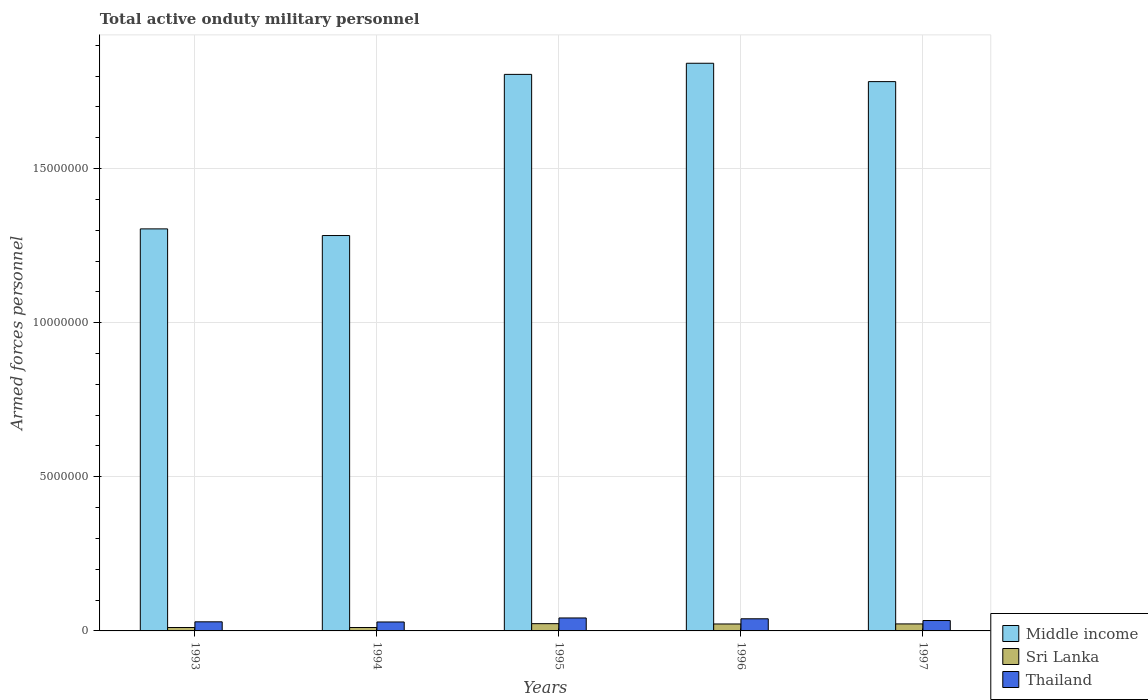How many different coloured bars are there?
Offer a very short reply. 3. How many bars are there on the 4th tick from the right?
Ensure brevity in your answer.  3. In how many cases, is the number of bars for a given year not equal to the number of legend labels?
Ensure brevity in your answer.  0. What is the number of armed forces personnel in Middle income in 1993?
Provide a succinct answer. 1.30e+07. Across all years, what is the maximum number of armed forces personnel in Thailand?
Ensure brevity in your answer.  4.20e+05. Across all years, what is the minimum number of armed forces personnel in Middle income?
Provide a short and direct response. 1.28e+07. What is the total number of armed forces personnel in Sri Lanka in the graph?
Make the answer very short. 9.08e+05. What is the difference between the number of armed forces personnel in Sri Lanka in 1993 and that in 1995?
Provide a succinct answer. -1.26e+05. What is the difference between the number of armed forces personnel in Thailand in 1993 and the number of armed forces personnel in Middle income in 1996?
Offer a very short reply. -1.81e+07. What is the average number of armed forces personnel in Middle income per year?
Offer a terse response. 1.60e+07. In the year 1995, what is the difference between the number of armed forces personnel in Middle income and number of armed forces personnel in Sri Lanka?
Keep it short and to the point. 1.78e+07. What is the ratio of the number of armed forces personnel in Thailand in 1993 to that in 1997?
Offer a terse response. 0.88. Is the difference between the number of armed forces personnel in Middle income in 1993 and 1996 greater than the difference between the number of armed forces personnel in Sri Lanka in 1993 and 1996?
Provide a succinct answer. No. What is the difference between the highest and the second highest number of armed forces personnel in Middle income?
Your response must be concise. 3.61e+05. What is the difference between the highest and the lowest number of armed forces personnel in Sri Lanka?
Provide a short and direct response. 1.26e+05. In how many years, is the number of armed forces personnel in Middle income greater than the average number of armed forces personnel in Middle income taken over all years?
Your response must be concise. 3. Is the sum of the number of armed forces personnel in Middle income in 1993 and 1994 greater than the maximum number of armed forces personnel in Sri Lanka across all years?
Ensure brevity in your answer.  Yes. What does the 2nd bar from the left in 1995 represents?
Keep it short and to the point. Sri Lanka. What does the 3rd bar from the right in 1993 represents?
Your answer should be compact. Middle income. Are all the bars in the graph horizontal?
Provide a succinct answer. No. How many years are there in the graph?
Your answer should be compact. 5. What is the difference between two consecutive major ticks on the Y-axis?
Your answer should be very brief. 5.00e+06. Are the values on the major ticks of Y-axis written in scientific E-notation?
Keep it short and to the point. No. Where does the legend appear in the graph?
Ensure brevity in your answer.  Bottom right. How many legend labels are there?
Your response must be concise. 3. What is the title of the graph?
Your answer should be compact. Total active onduty military personnel. What is the label or title of the X-axis?
Offer a very short reply. Years. What is the label or title of the Y-axis?
Give a very brief answer. Armed forces personnel. What is the Armed forces personnel of Middle income in 1993?
Your answer should be very brief. 1.30e+07. What is the Armed forces personnel of Sri Lanka in 1993?
Provide a short and direct response. 1.10e+05. What is the Armed forces personnel in Thailand in 1993?
Offer a terse response. 2.95e+05. What is the Armed forces personnel of Middle income in 1994?
Provide a succinct answer. 1.28e+07. What is the Armed forces personnel of Sri Lanka in 1994?
Give a very brief answer. 1.10e+05. What is the Armed forces personnel of Thailand in 1994?
Your response must be concise. 2.90e+05. What is the Armed forces personnel in Middle income in 1995?
Your answer should be compact. 1.81e+07. What is the Armed forces personnel in Sri Lanka in 1995?
Offer a very short reply. 2.36e+05. What is the Armed forces personnel of Thailand in 1995?
Your response must be concise. 4.20e+05. What is the Armed forces personnel of Middle income in 1996?
Offer a terse response. 1.84e+07. What is the Armed forces personnel in Sri Lanka in 1996?
Give a very brief answer. 2.25e+05. What is the Armed forces personnel of Thailand in 1996?
Make the answer very short. 3.94e+05. What is the Armed forces personnel in Middle income in 1997?
Provide a succinct answer. 1.78e+07. What is the Armed forces personnel in Sri Lanka in 1997?
Offer a very short reply. 2.27e+05. What is the Armed forces personnel of Thailand in 1997?
Offer a terse response. 3.37e+05. Across all years, what is the maximum Armed forces personnel of Middle income?
Offer a terse response. 1.84e+07. Across all years, what is the maximum Armed forces personnel of Sri Lanka?
Give a very brief answer. 2.36e+05. Across all years, what is the maximum Armed forces personnel in Thailand?
Keep it short and to the point. 4.20e+05. Across all years, what is the minimum Armed forces personnel in Middle income?
Your answer should be compact. 1.28e+07. What is the total Armed forces personnel of Middle income in the graph?
Your response must be concise. 8.02e+07. What is the total Armed forces personnel of Sri Lanka in the graph?
Provide a short and direct response. 9.08e+05. What is the total Armed forces personnel of Thailand in the graph?
Give a very brief answer. 1.74e+06. What is the difference between the Armed forces personnel of Middle income in 1993 and that in 1994?
Make the answer very short. 2.16e+05. What is the difference between the Armed forces personnel of Sri Lanka in 1993 and that in 1994?
Your answer should be very brief. 0. What is the difference between the Armed forces personnel in Thailand in 1993 and that in 1994?
Your response must be concise. 5000. What is the difference between the Armed forces personnel in Middle income in 1993 and that in 1995?
Offer a very short reply. -5.01e+06. What is the difference between the Armed forces personnel of Sri Lanka in 1993 and that in 1995?
Offer a terse response. -1.26e+05. What is the difference between the Armed forces personnel in Thailand in 1993 and that in 1995?
Make the answer very short. -1.26e+05. What is the difference between the Armed forces personnel of Middle income in 1993 and that in 1996?
Keep it short and to the point. -5.37e+06. What is the difference between the Armed forces personnel in Sri Lanka in 1993 and that in 1996?
Your answer should be compact. -1.15e+05. What is the difference between the Armed forces personnel in Thailand in 1993 and that in 1996?
Your answer should be compact. -9.85e+04. What is the difference between the Armed forces personnel in Middle income in 1993 and that in 1997?
Provide a short and direct response. -4.78e+06. What is the difference between the Armed forces personnel of Sri Lanka in 1993 and that in 1997?
Make the answer very short. -1.17e+05. What is the difference between the Armed forces personnel of Thailand in 1993 and that in 1997?
Provide a short and direct response. -4.20e+04. What is the difference between the Armed forces personnel in Middle income in 1994 and that in 1995?
Provide a short and direct response. -5.23e+06. What is the difference between the Armed forces personnel of Sri Lanka in 1994 and that in 1995?
Your answer should be very brief. -1.26e+05. What is the difference between the Armed forces personnel in Thailand in 1994 and that in 1995?
Your response must be concise. -1.30e+05. What is the difference between the Armed forces personnel in Middle income in 1994 and that in 1996?
Provide a short and direct response. -5.59e+06. What is the difference between the Armed forces personnel in Sri Lanka in 1994 and that in 1996?
Offer a terse response. -1.15e+05. What is the difference between the Armed forces personnel in Thailand in 1994 and that in 1996?
Ensure brevity in your answer.  -1.04e+05. What is the difference between the Armed forces personnel of Middle income in 1994 and that in 1997?
Keep it short and to the point. -4.99e+06. What is the difference between the Armed forces personnel of Sri Lanka in 1994 and that in 1997?
Give a very brief answer. -1.17e+05. What is the difference between the Armed forces personnel in Thailand in 1994 and that in 1997?
Your answer should be compact. -4.70e+04. What is the difference between the Armed forces personnel of Middle income in 1995 and that in 1996?
Keep it short and to the point. -3.61e+05. What is the difference between the Armed forces personnel in Sri Lanka in 1995 and that in 1996?
Keep it short and to the point. 1.03e+04. What is the difference between the Armed forces personnel in Thailand in 1995 and that in 1996?
Offer a very short reply. 2.70e+04. What is the difference between the Armed forces personnel in Middle income in 1995 and that in 1997?
Your response must be concise. 2.35e+05. What is the difference between the Armed forces personnel of Sri Lanka in 1995 and that in 1997?
Give a very brief answer. 8300. What is the difference between the Armed forces personnel in Thailand in 1995 and that in 1997?
Offer a very short reply. 8.35e+04. What is the difference between the Armed forces personnel in Middle income in 1996 and that in 1997?
Provide a short and direct response. 5.96e+05. What is the difference between the Armed forces personnel of Sri Lanka in 1996 and that in 1997?
Offer a very short reply. -2000. What is the difference between the Armed forces personnel in Thailand in 1996 and that in 1997?
Offer a very short reply. 5.65e+04. What is the difference between the Armed forces personnel of Middle income in 1993 and the Armed forces personnel of Sri Lanka in 1994?
Offer a terse response. 1.29e+07. What is the difference between the Armed forces personnel in Middle income in 1993 and the Armed forces personnel in Thailand in 1994?
Provide a short and direct response. 1.28e+07. What is the difference between the Armed forces personnel in Sri Lanka in 1993 and the Armed forces personnel in Thailand in 1994?
Your response must be concise. -1.80e+05. What is the difference between the Armed forces personnel of Middle income in 1993 and the Armed forces personnel of Sri Lanka in 1995?
Keep it short and to the point. 1.28e+07. What is the difference between the Armed forces personnel in Middle income in 1993 and the Armed forces personnel in Thailand in 1995?
Your response must be concise. 1.26e+07. What is the difference between the Armed forces personnel of Sri Lanka in 1993 and the Armed forces personnel of Thailand in 1995?
Make the answer very short. -3.10e+05. What is the difference between the Armed forces personnel in Middle income in 1993 and the Armed forces personnel in Sri Lanka in 1996?
Give a very brief answer. 1.28e+07. What is the difference between the Armed forces personnel of Middle income in 1993 and the Armed forces personnel of Thailand in 1996?
Your response must be concise. 1.26e+07. What is the difference between the Armed forces personnel of Sri Lanka in 1993 and the Armed forces personnel of Thailand in 1996?
Make the answer very short. -2.84e+05. What is the difference between the Armed forces personnel of Middle income in 1993 and the Armed forces personnel of Sri Lanka in 1997?
Offer a very short reply. 1.28e+07. What is the difference between the Armed forces personnel in Middle income in 1993 and the Armed forces personnel in Thailand in 1997?
Keep it short and to the point. 1.27e+07. What is the difference between the Armed forces personnel in Sri Lanka in 1993 and the Armed forces personnel in Thailand in 1997?
Offer a very short reply. -2.27e+05. What is the difference between the Armed forces personnel in Middle income in 1994 and the Armed forces personnel in Sri Lanka in 1995?
Provide a short and direct response. 1.26e+07. What is the difference between the Armed forces personnel of Middle income in 1994 and the Armed forces personnel of Thailand in 1995?
Provide a succinct answer. 1.24e+07. What is the difference between the Armed forces personnel in Sri Lanka in 1994 and the Armed forces personnel in Thailand in 1995?
Your answer should be compact. -3.10e+05. What is the difference between the Armed forces personnel of Middle income in 1994 and the Armed forces personnel of Sri Lanka in 1996?
Your response must be concise. 1.26e+07. What is the difference between the Armed forces personnel of Middle income in 1994 and the Armed forces personnel of Thailand in 1996?
Offer a terse response. 1.24e+07. What is the difference between the Armed forces personnel of Sri Lanka in 1994 and the Armed forces personnel of Thailand in 1996?
Your answer should be compact. -2.84e+05. What is the difference between the Armed forces personnel in Middle income in 1994 and the Armed forces personnel in Sri Lanka in 1997?
Give a very brief answer. 1.26e+07. What is the difference between the Armed forces personnel in Middle income in 1994 and the Armed forces personnel in Thailand in 1997?
Your response must be concise. 1.25e+07. What is the difference between the Armed forces personnel in Sri Lanka in 1994 and the Armed forces personnel in Thailand in 1997?
Your response must be concise. -2.27e+05. What is the difference between the Armed forces personnel in Middle income in 1995 and the Armed forces personnel in Sri Lanka in 1996?
Your answer should be very brief. 1.78e+07. What is the difference between the Armed forces personnel of Middle income in 1995 and the Armed forces personnel of Thailand in 1996?
Offer a terse response. 1.77e+07. What is the difference between the Armed forces personnel of Sri Lanka in 1995 and the Armed forces personnel of Thailand in 1996?
Give a very brief answer. -1.58e+05. What is the difference between the Armed forces personnel of Middle income in 1995 and the Armed forces personnel of Sri Lanka in 1997?
Ensure brevity in your answer.  1.78e+07. What is the difference between the Armed forces personnel of Middle income in 1995 and the Armed forces personnel of Thailand in 1997?
Offer a terse response. 1.77e+07. What is the difference between the Armed forces personnel of Sri Lanka in 1995 and the Armed forces personnel of Thailand in 1997?
Your answer should be very brief. -1.02e+05. What is the difference between the Armed forces personnel in Middle income in 1996 and the Armed forces personnel in Sri Lanka in 1997?
Make the answer very short. 1.82e+07. What is the difference between the Armed forces personnel of Middle income in 1996 and the Armed forces personnel of Thailand in 1997?
Your response must be concise. 1.81e+07. What is the difference between the Armed forces personnel of Sri Lanka in 1996 and the Armed forces personnel of Thailand in 1997?
Your answer should be compact. -1.12e+05. What is the average Armed forces personnel in Middle income per year?
Offer a very short reply. 1.60e+07. What is the average Armed forces personnel of Sri Lanka per year?
Offer a very short reply. 1.82e+05. What is the average Armed forces personnel of Thailand per year?
Ensure brevity in your answer.  3.47e+05. In the year 1993, what is the difference between the Armed forces personnel in Middle income and Armed forces personnel in Sri Lanka?
Make the answer very short. 1.29e+07. In the year 1993, what is the difference between the Armed forces personnel of Middle income and Armed forces personnel of Thailand?
Offer a very short reply. 1.27e+07. In the year 1993, what is the difference between the Armed forces personnel in Sri Lanka and Armed forces personnel in Thailand?
Offer a very short reply. -1.85e+05. In the year 1994, what is the difference between the Armed forces personnel of Middle income and Armed forces personnel of Sri Lanka?
Your response must be concise. 1.27e+07. In the year 1994, what is the difference between the Armed forces personnel in Middle income and Armed forces personnel in Thailand?
Provide a short and direct response. 1.25e+07. In the year 1995, what is the difference between the Armed forces personnel in Middle income and Armed forces personnel in Sri Lanka?
Your answer should be compact. 1.78e+07. In the year 1995, what is the difference between the Armed forces personnel of Middle income and Armed forces personnel of Thailand?
Your answer should be very brief. 1.76e+07. In the year 1995, what is the difference between the Armed forces personnel in Sri Lanka and Armed forces personnel in Thailand?
Give a very brief answer. -1.85e+05. In the year 1996, what is the difference between the Armed forces personnel of Middle income and Armed forces personnel of Sri Lanka?
Provide a succinct answer. 1.82e+07. In the year 1996, what is the difference between the Armed forces personnel in Middle income and Armed forces personnel in Thailand?
Ensure brevity in your answer.  1.80e+07. In the year 1996, what is the difference between the Armed forces personnel in Sri Lanka and Armed forces personnel in Thailand?
Make the answer very short. -1.68e+05. In the year 1997, what is the difference between the Armed forces personnel in Middle income and Armed forces personnel in Sri Lanka?
Make the answer very short. 1.76e+07. In the year 1997, what is the difference between the Armed forces personnel in Middle income and Armed forces personnel in Thailand?
Provide a short and direct response. 1.75e+07. In the year 1997, what is the difference between the Armed forces personnel of Sri Lanka and Armed forces personnel of Thailand?
Provide a short and direct response. -1.10e+05. What is the ratio of the Armed forces personnel of Middle income in 1993 to that in 1994?
Give a very brief answer. 1.02. What is the ratio of the Armed forces personnel in Sri Lanka in 1993 to that in 1994?
Offer a terse response. 1. What is the ratio of the Armed forces personnel of Thailand in 1993 to that in 1994?
Provide a short and direct response. 1.02. What is the ratio of the Armed forces personnel of Middle income in 1993 to that in 1995?
Ensure brevity in your answer.  0.72. What is the ratio of the Armed forces personnel of Sri Lanka in 1993 to that in 1995?
Make the answer very short. 0.47. What is the ratio of the Armed forces personnel in Thailand in 1993 to that in 1995?
Provide a succinct answer. 0.7. What is the ratio of the Armed forces personnel in Middle income in 1993 to that in 1996?
Make the answer very short. 0.71. What is the ratio of the Armed forces personnel in Sri Lanka in 1993 to that in 1996?
Provide a short and direct response. 0.49. What is the ratio of the Armed forces personnel of Thailand in 1993 to that in 1996?
Offer a terse response. 0.75. What is the ratio of the Armed forces personnel in Middle income in 1993 to that in 1997?
Your response must be concise. 0.73. What is the ratio of the Armed forces personnel of Sri Lanka in 1993 to that in 1997?
Your answer should be very brief. 0.48. What is the ratio of the Armed forces personnel in Thailand in 1993 to that in 1997?
Offer a terse response. 0.88. What is the ratio of the Armed forces personnel in Middle income in 1994 to that in 1995?
Offer a very short reply. 0.71. What is the ratio of the Armed forces personnel of Sri Lanka in 1994 to that in 1995?
Provide a short and direct response. 0.47. What is the ratio of the Armed forces personnel of Thailand in 1994 to that in 1995?
Your answer should be very brief. 0.69. What is the ratio of the Armed forces personnel of Middle income in 1994 to that in 1996?
Provide a succinct answer. 0.7. What is the ratio of the Armed forces personnel of Sri Lanka in 1994 to that in 1996?
Give a very brief answer. 0.49. What is the ratio of the Armed forces personnel of Thailand in 1994 to that in 1996?
Provide a short and direct response. 0.74. What is the ratio of the Armed forces personnel in Middle income in 1994 to that in 1997?
Provide a succinct answer. 0.72. What is the ratio of the Armed forces personnel of Sri Lanka in 1994 to that in 1997?
Keep it short and to the point. 0.48. What is the ratio of the Armed forces personnel of Thailand in 1994 to that in 1997?
Keep it short and to the point. 0.86. What is the ratio of the Armed forces personnel of Middle income in 1995 to that in 1996?
Your response must be concise. 0.98. What is the ratio of the Armed forces personnel of Sri Lanka in 1995 to that in 1996?
Offer a terse response. 1.05. What is the ratio of the Armed forces personnel of Thailand in 1995 to that in 1996?
Your answer should be very brief. 1.07. What is the ratio of the Armed forces personnel in Middle income in 1995 to that in 1997?
Provide a short and direct response. 1.01. What is the ratio of the Armed forces personnel in Sri Lanka in 1995 to that in 1997?
Provide a short and direct response. 1.04. What is the ratio of the Armed forces personnel in Thailand in 1995 to that in 1997?
Make the answer very short. 1.25. What is the ratio of the Armed forces personnel in Middle income in 1996 to that in 1997?
Give a very brief answer. 1.03. What is the ratio of the Armed forces personnel in Thailand in 1996 to that in 1997?
Your answer should be very brief. 1.17. What is the difference between the highest and the second highest Armed forces personnel of Middle income?
Provide a succinct answer. 3.61e+05. What is the difference between the highest and the second highest Armed forces personnel of Sri Lanka?
Your answer should be compact. 8300. What is the difference between the highest and the second highest Armed forces personnel in Thailand?
Your answer should be very brief. 2.70e+04. What is the difference between the highest and the lowest Armed forces personnel of Middle income?
Ensure brevity in your answer.  5.59e+06. What is the difference between the highest and the lowest Armed forces personnel in Sri Lanka?
Your response must be concise. 1.26e+05. What is the difference between the highest and the lowest Armed forces personnel in Thailand?
Ensure brevity in your answer.  1.30e+05. 